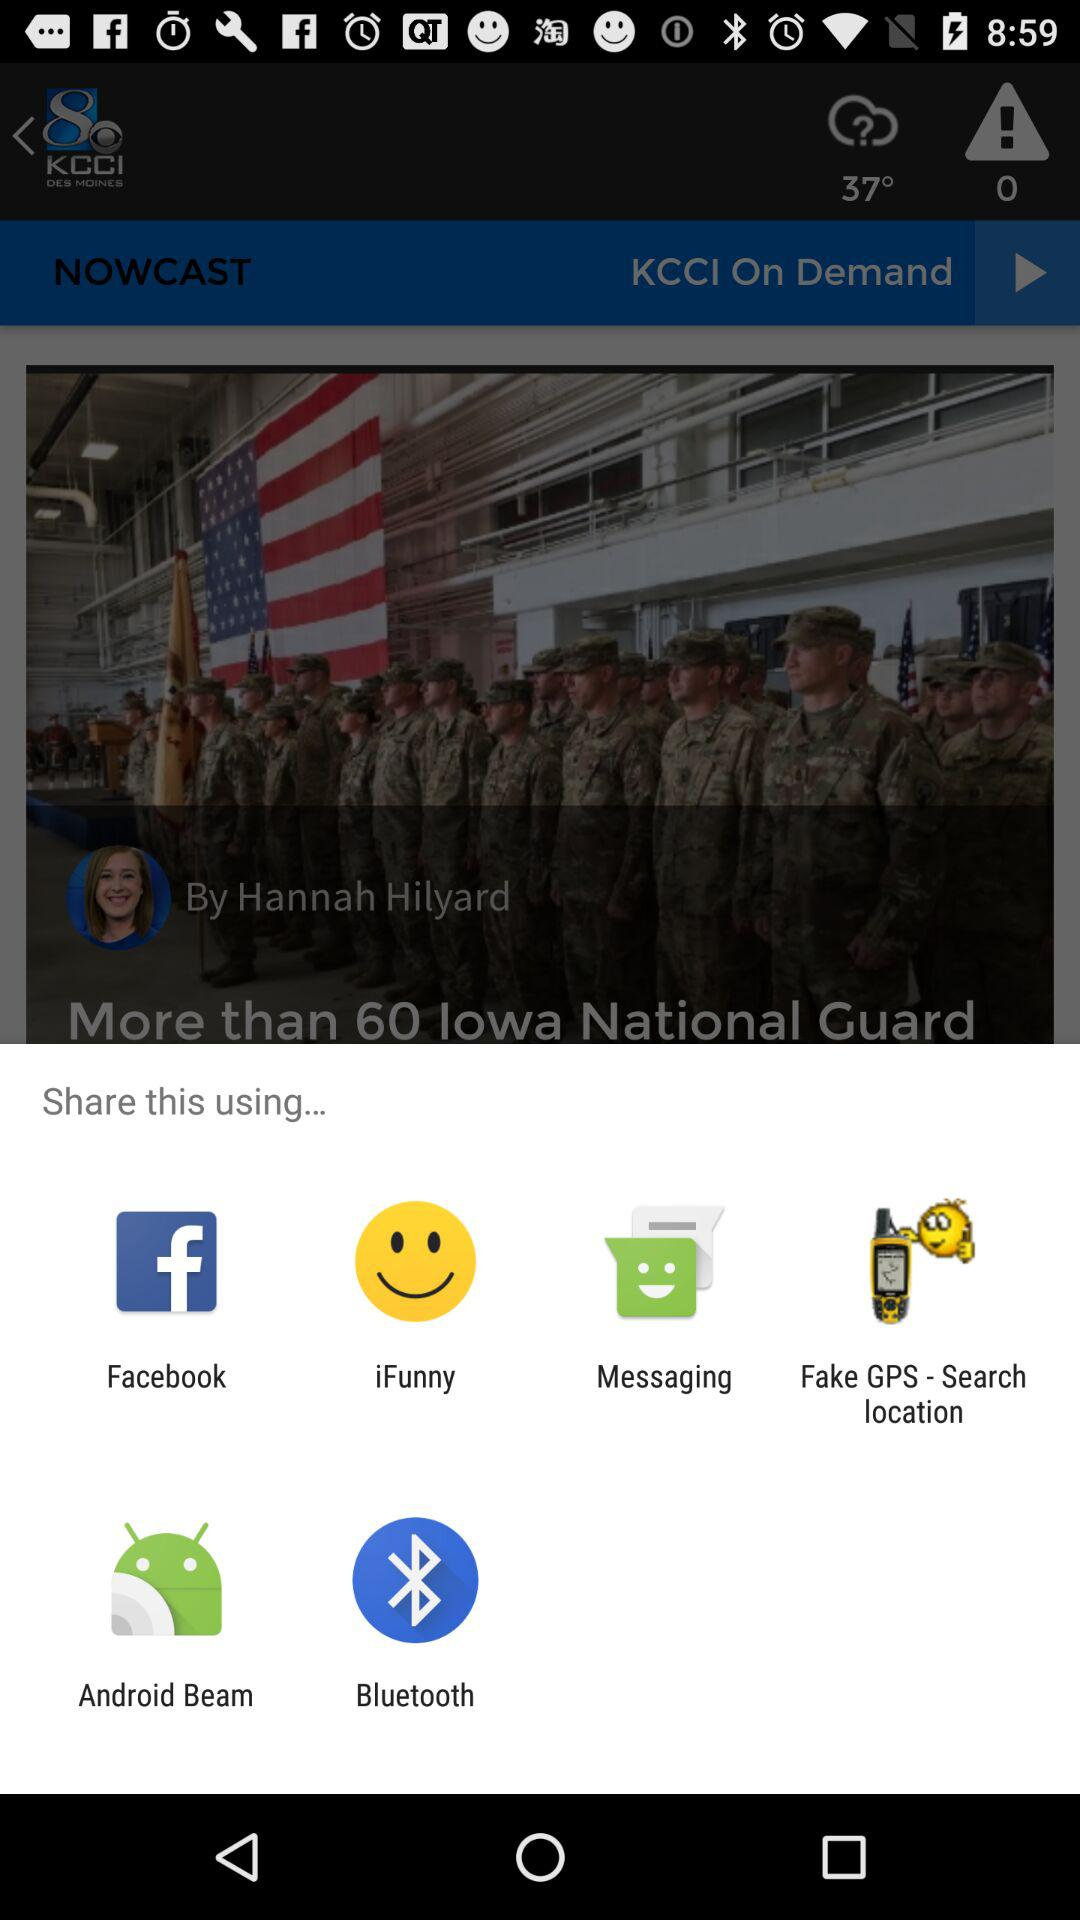How many likes are on this article?
When the provided information is insufficient, respond with <no answer>. <no answer> 